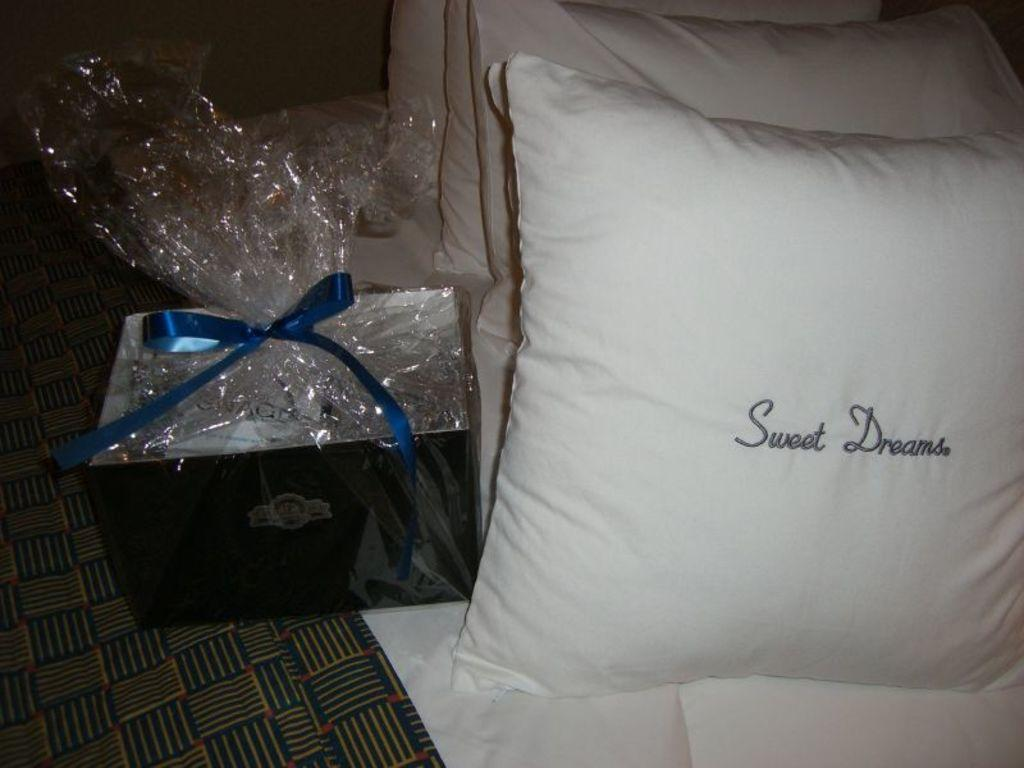What type of objects can be seen in the image? There are pillows in the image. What color are the pillows? The pillows are white in color. What is located to the left in the image? There is a box to the left in the image. What is at the bottom of the image? There is a bed sheet at the bottom of the image. What riddle is being solved by the pillows in the image? There is no riddle being solved by the pillows in the image; they are simply objects in the scene. 